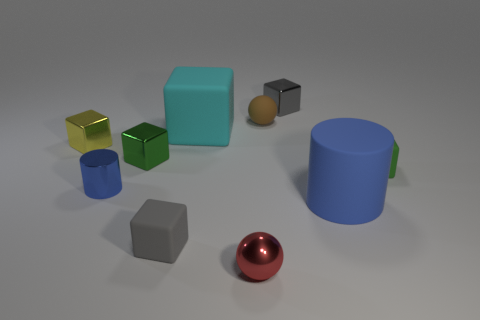Subtract all cyan blocks. How many blocks are left? 5 Subtract 1 blocks. How many blocks are left? 5 Subtract all green rubber cubes. How many cubes are left? 5 Subtract all blue blocks. Subtract all yellow cylinders. How many blocks are left? 6 Subtract all balls. How many objects are left? 8 Add 7 gray cubes. How many gray cubes are left? 9 Add 8 small purple balls. How many small purple balls exist? 8 Subtract 1 yellow cubes. How many objects are left? 9 Subtract all gray cylinders. Subtract all cyan cubes. How many objects are left? 9 